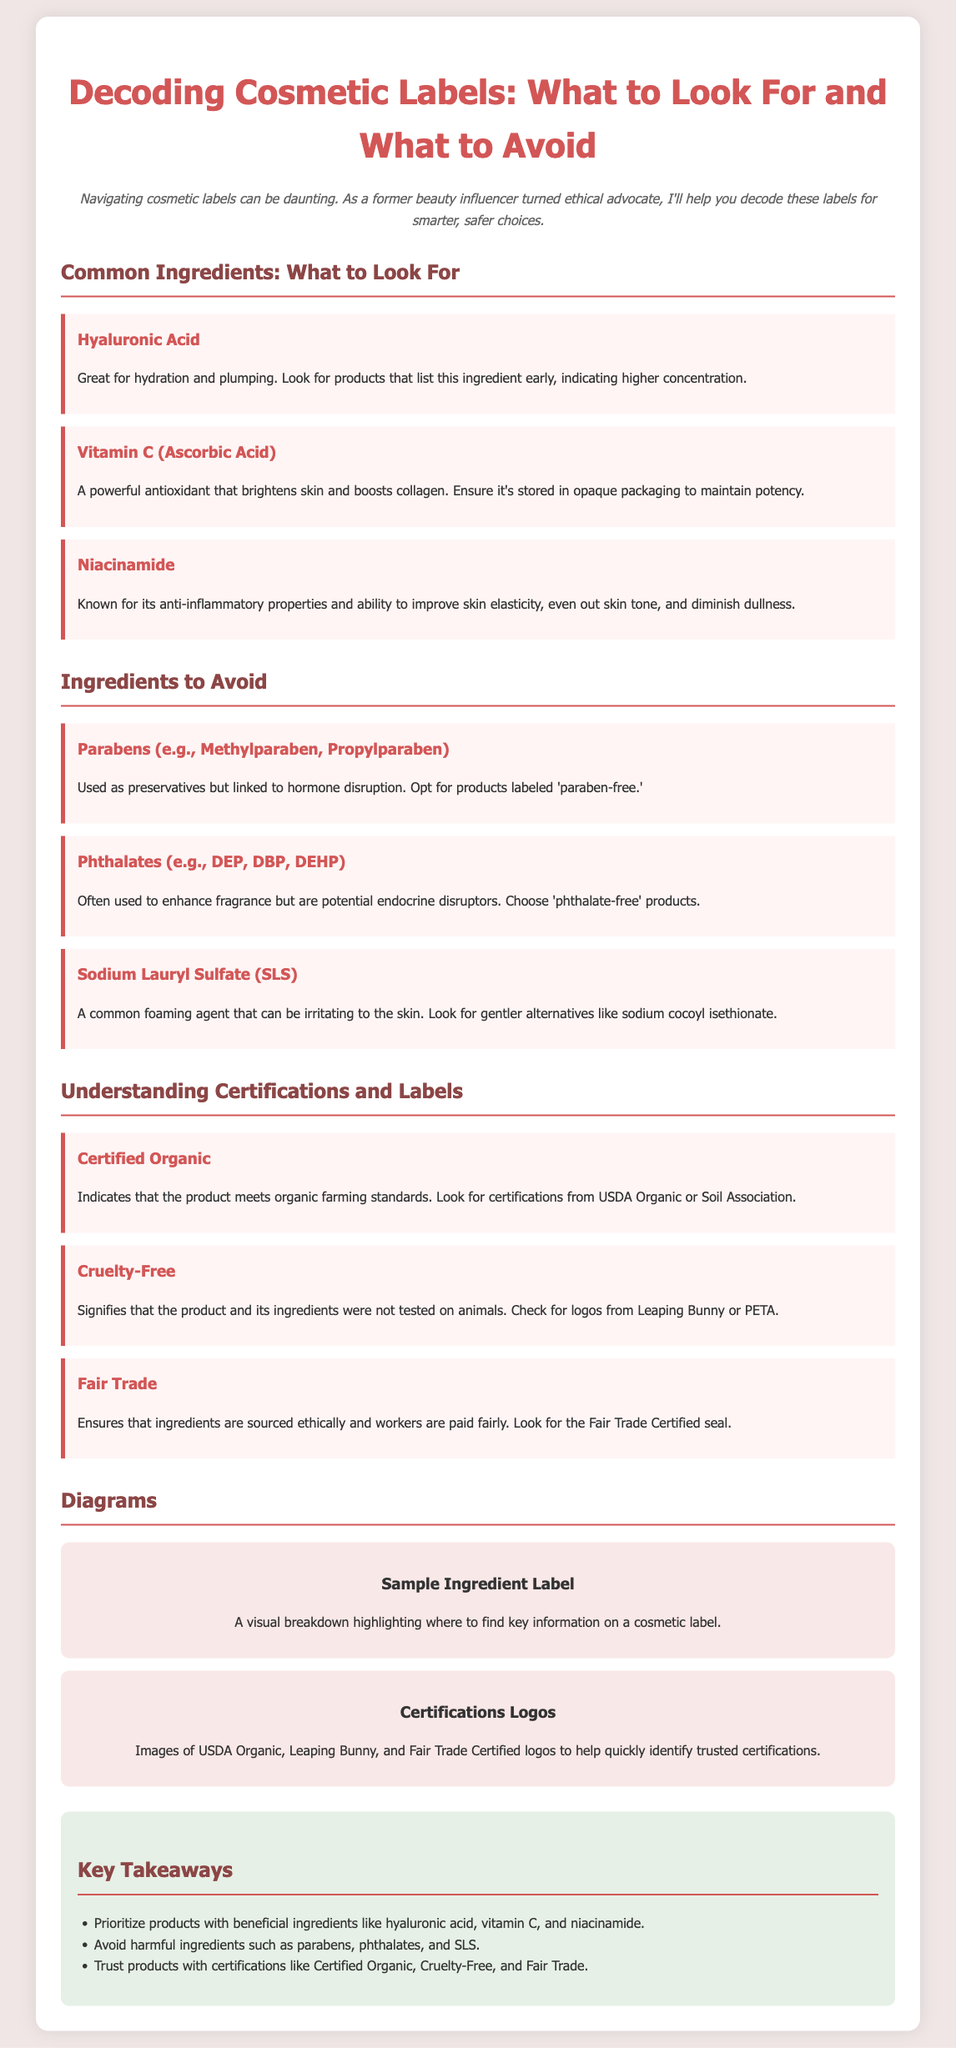What is the title of the presentation? The title is prominently displayed at the top of the document and serves as the main subject.
Answer: Decoding Cosmetic Labels: What to Look For and What to Avoid What ingredient is known for hydration and plumping? This ingredient is listed under "Common Ingredients: What to Look For" and is highlighted for its benefits.
Answer: Hyaluronic Acid Which organization certifies organic products? The section on "Understanding Certifications and Labels" mentions this organization as a marker of organic standards.
Answer: USDA Organic What ingredient should be avoided due to hormone disruption? This ingredient is found in the "Ingredients to Avoid" section, which advises against its use.
Answer: Parabens What does "Cruelty-Free" signify? The document explains this term under certifications, indicating the ethical treatment connected with the product testing.
Answer: Not tested on animals How many common ingredients are recommended in the document? The "Common Ingredients: What to Look For" section lists three specific ingredients.
Answer: Three What is one of the ethical attributes of Fair Trade? The document describes this certification under "Understanding Certifications and Labels," emphasizing fair compensation.
Answer: Workers are paid fairly What is indicated by a product labeled as 'phthalate-free'? This label is discussed in the "Ingredients to Avoid" section, signifying the absence of specific harmful ingredients.
Answer: No phthalates What is the main theme of the presentation? The presentation focuses on guiding consumers to make informed choices regarding cosmetic products by understanding labels and ingredients.
Answer: Educating consumers about cosmetic labels and ingredients 